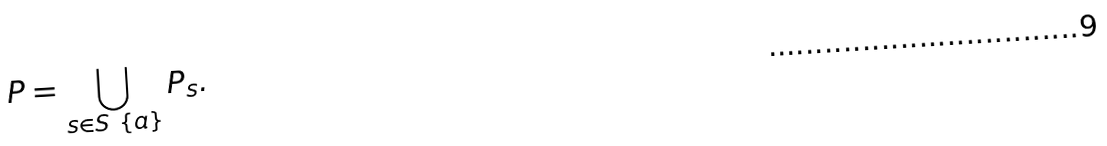<formula> <loc_0><loc_0><loc_500><loc_500>P = \bigcup _ { s \in S \ \{ a \} } { P _ { s } } .</formula> 